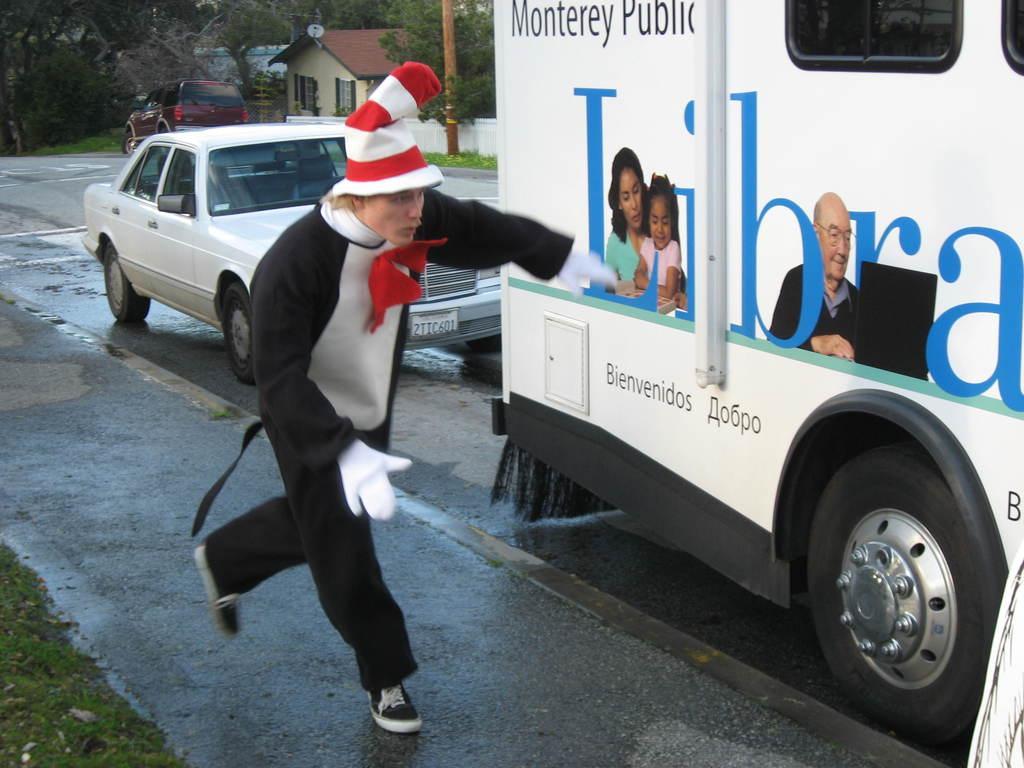Please provide a concise description of this image. In this image in the center there is one person who is wearing same costume and walking, and there are some vehicles. And in the background there is a house, pole, wall, trees and one vehicle. At the bottom there is road and grass. 